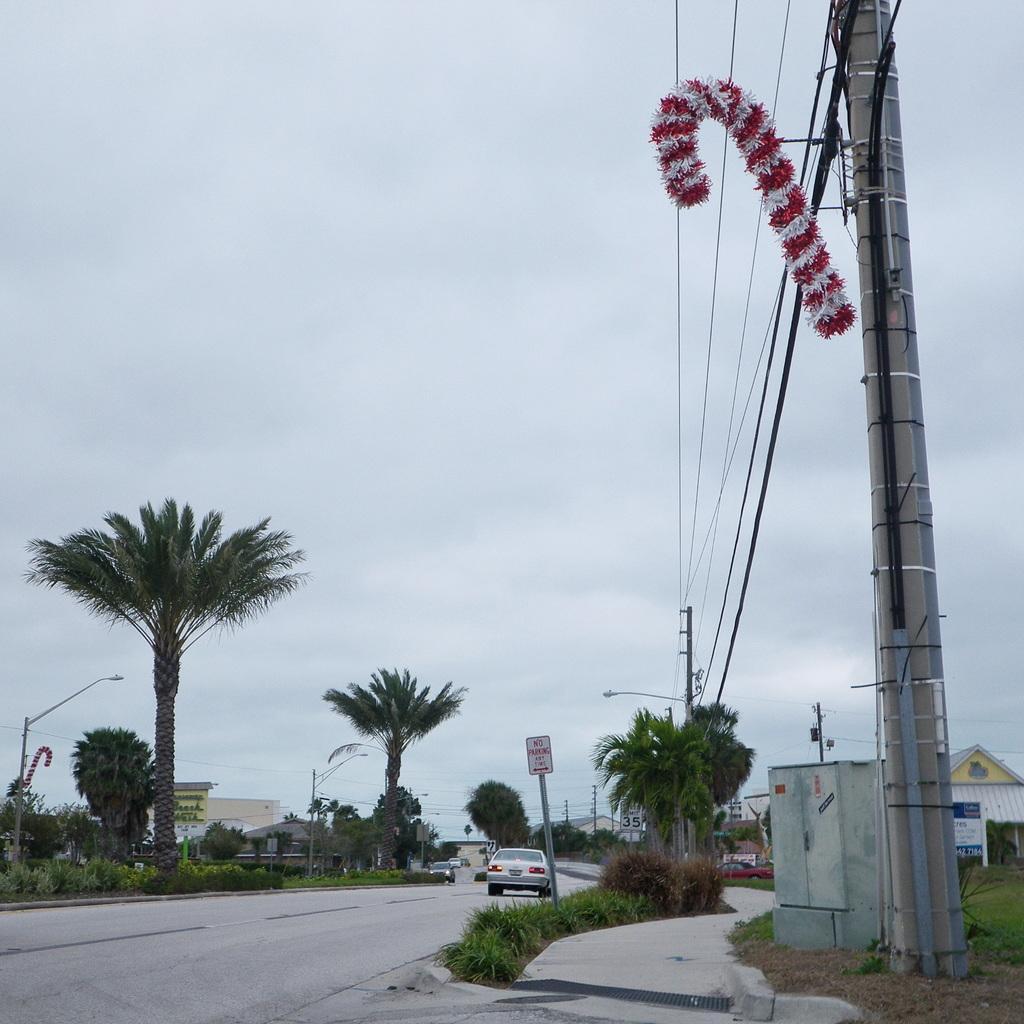Please provide a concise description of this image. In this image in the center there is a road, on the road there are some vehicles and on the right side and left side there are some trees, buildings, poles, wires and at the top of the image there is sky. 